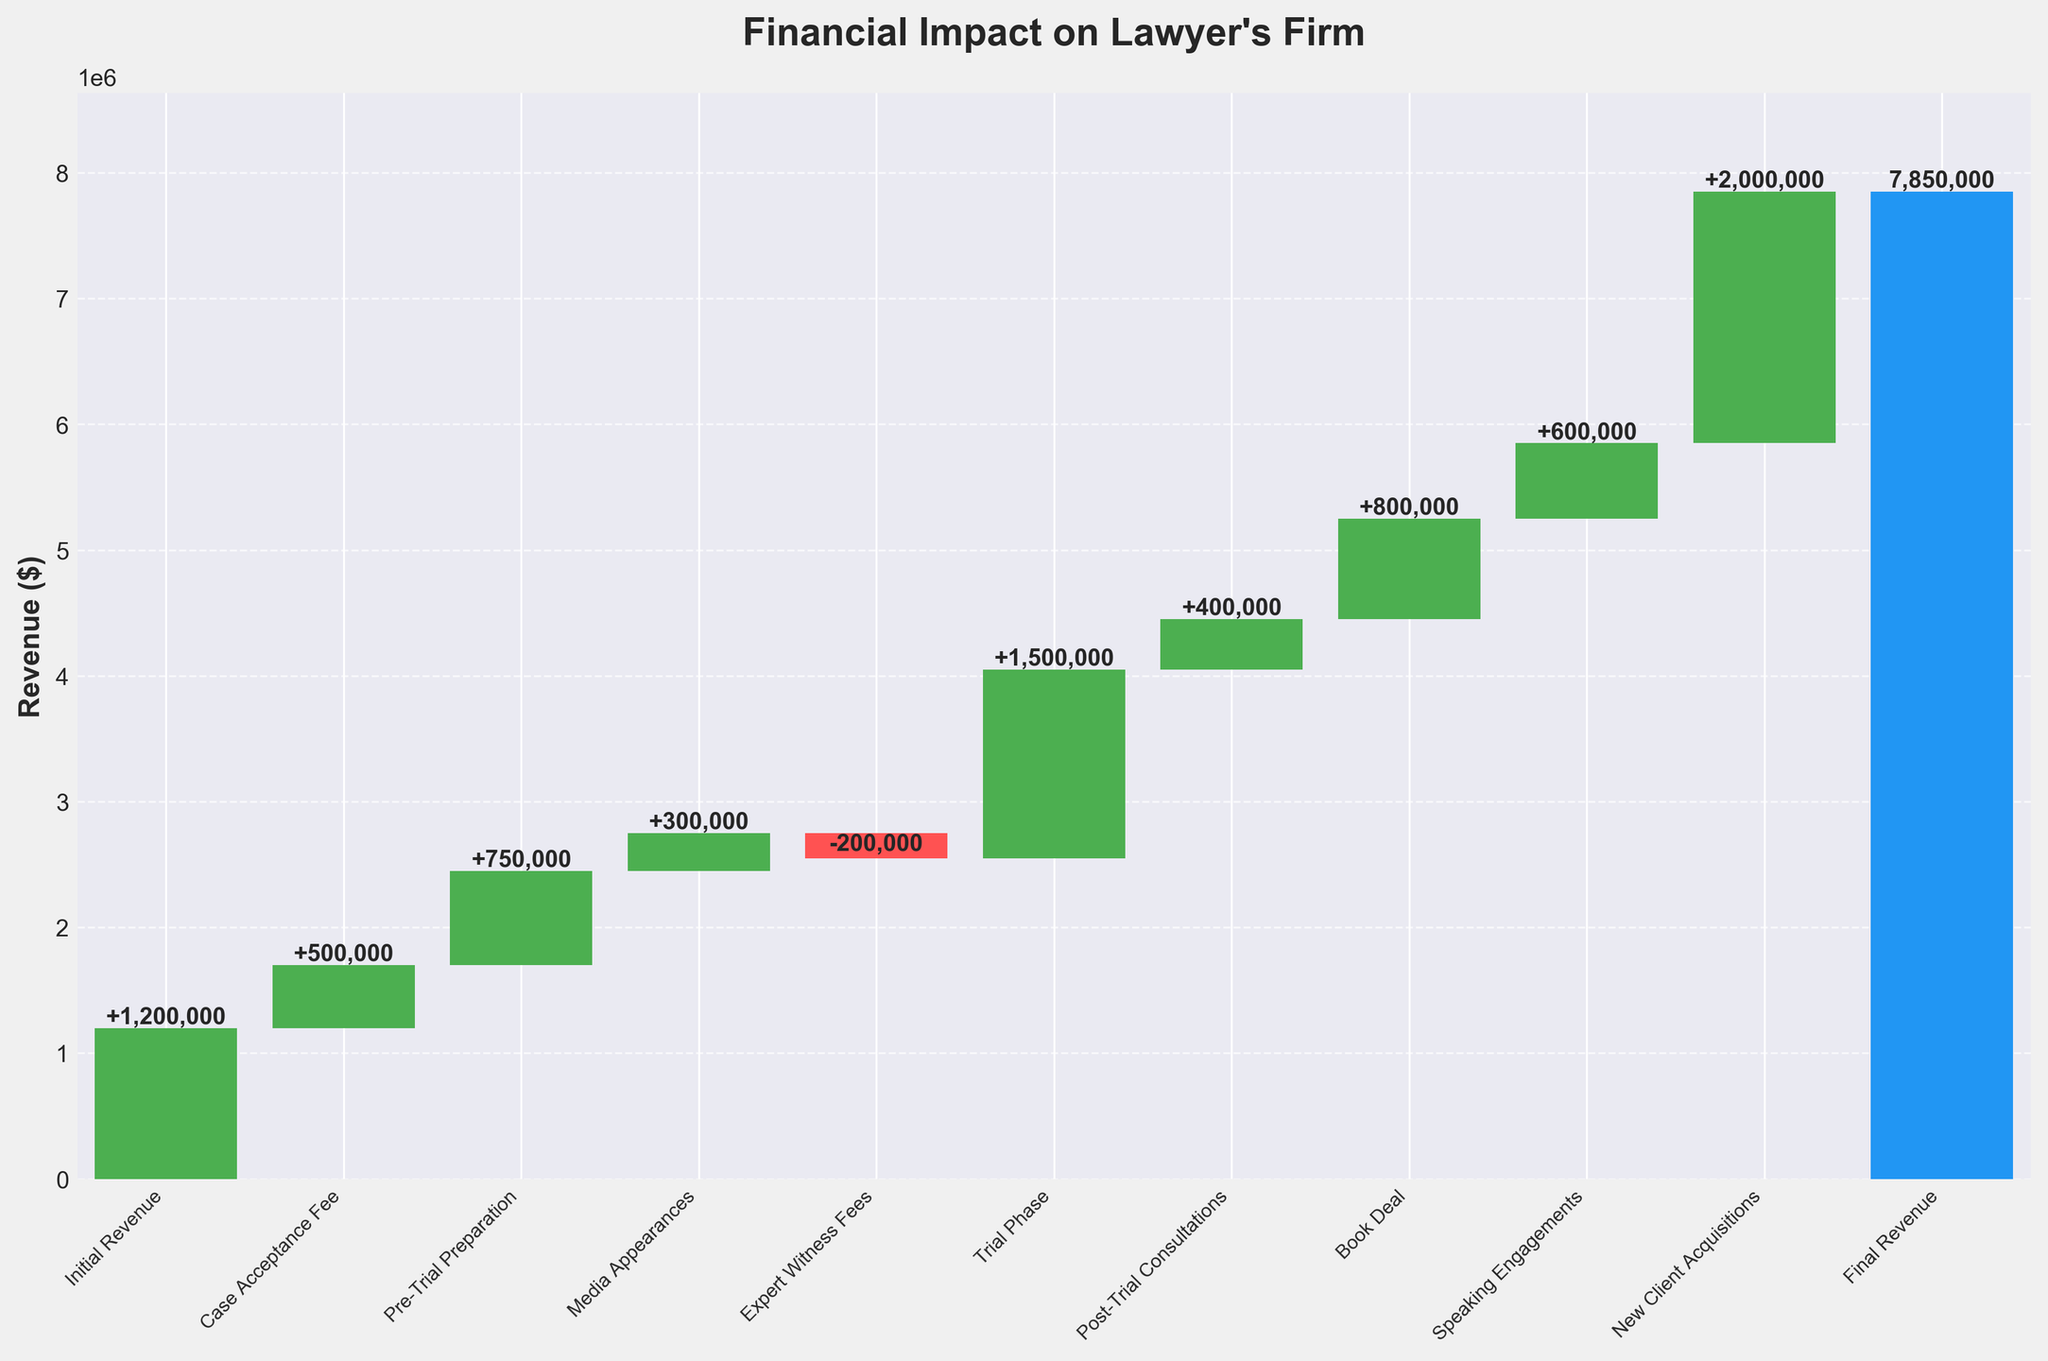What is the title of the chart? The chart title is displayed at the top in bold text.
Answer: Financial Impact on Lawyer's Firm How many categories are shown in the waterfall chart? Count the total number of bars in the chart, including the final revenue bar.
Answer: 10 Which category contributes the most to the total revenue? Identify the bar with the highest positive value.
Answer: New Client Acquisitions What is the final revenue shown in the chart? The final bar represents the cumulative revenue, the value is labeled on this bar.
Answer: $7,850,000 How does the expert witness fee impact the firm's revenue? Identify the bar representing Expert Witness Fees and note if it is positive or negative.
Answer: Decreases revenue by $200,000 